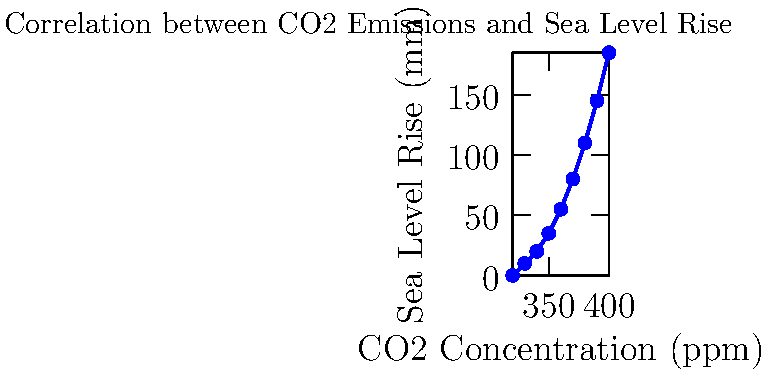Based on the scatter plot showing the relationship between CO2 concentration and sea level rise, what can be inferred about the impact of increasing CO2 emissions on sea levels? To answer this question, we need to analyze the scatter plot and interpret the relationship between CO2 concentration and sea level rise:

1. Observe the overall trend: The points in the scatter plot show a clear upward trend from left to right.

2. Understand the axes:
   - X-axis represents CO2 concentration in parts per million (ppm)
   - Y-axis represents sea level rise in millimeters (mm)

3. Analyze the relationship:
   - As CO2 concentration increases, sea level rise also increases
   - The relationship appears to be non-linear, with sea level rise accelerating as CO2 concentration increases

4. Consider the implications:
   - The plot suggests a positive correlation between CO2 emissions and sea level rise
   - This correlation implies that increasing CO2 emissions may contribute to rising sea levels

5. Recognize limitations:
   - Correlation does not necessarily imply causation
   - Other factors may also influence sea level rise

6. Draw a conclusion:
   - The data suggests that increasing CO2 emissions likely have a significant impact on sea level rise
   - This relationship underscores the potential environmental consequences of continued CO2 emissions
Answer: Positive correlation; increasing CO2 emissions likely contribute to accelerating sea level rise. 